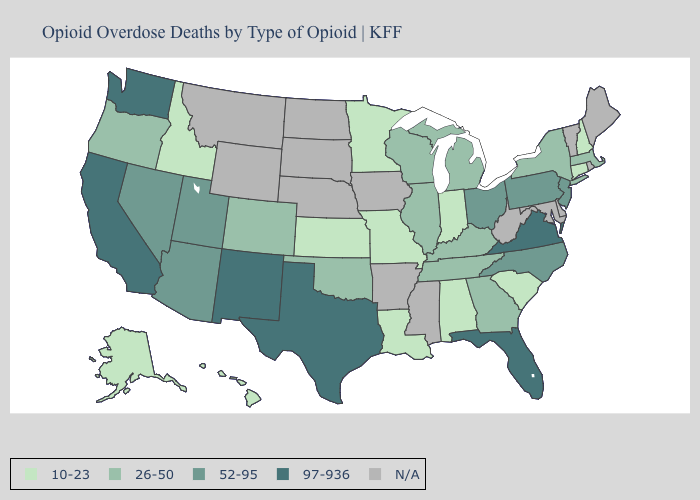What is the value of Oklahoma?
Write a very short answer. 26-50. Among the states that border Michigan , does Wisconsin have the highest value?
Answer briefly. No. Which states hav the highest value in the Northeast?
Concise answer only. New Jersey, Pennsylvania. Among the states that border New Hampshire , which have the lowest value?
Keep it brief. Massachusetts. Does Oregon have the highest value in the West?
Concise answer only. No. Among the states that border Mississippi , which have the lowest value?
Quick response, please. Alabama, Louisiana. What is the value of Kentucky?
Quick response, please. 26-50. What is the value of Nebraska?
Short answer required. N/A. What is the highest value in the South ?
Short answer required. 97-936. How many symbols are there in the legend?
Concise answer only. 5. What is the value of Maryland?
Concise answer only. N/A. Which states hav the highest value in the MidWest?
Concise answer only. Ohio. 